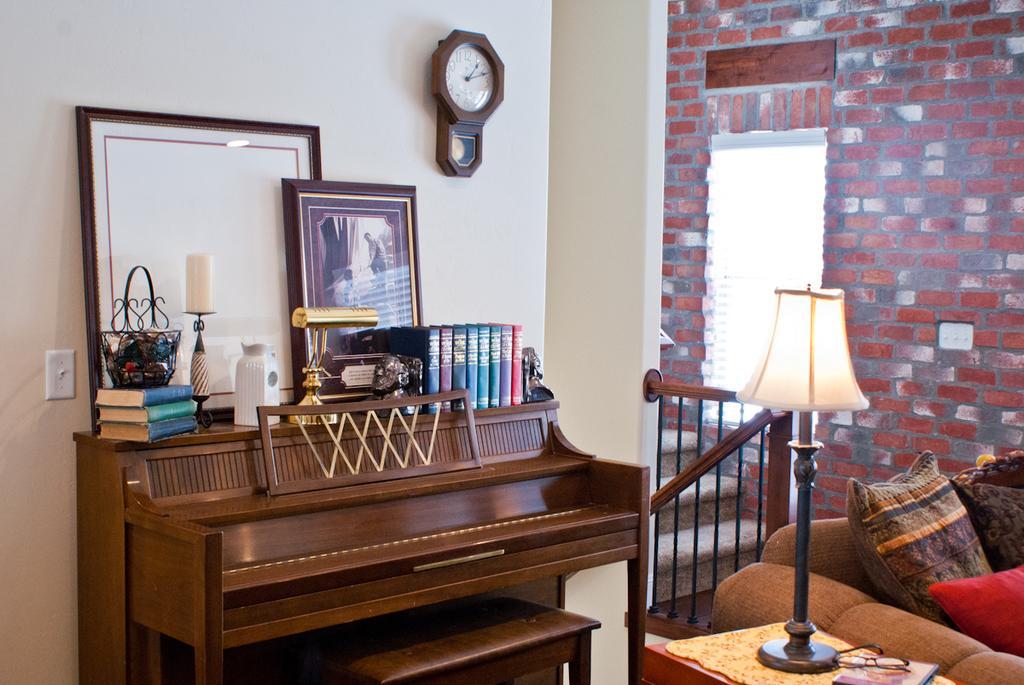Describe this image in one or two sentences. This picture is clicked inside the room and in front of the picture, we see a table on which lamp, basket, books, jar, photo frame and board are placed on it. Behind that, we see a white wall on which clock watch is placed. Beside that, we see staircase. In front of the picture on the right bottom, we see a red table on which lamp is placed and beside that, we see sofa containing two pillows and on the right top the picture, we see a wall which is made up of red color bricks. 